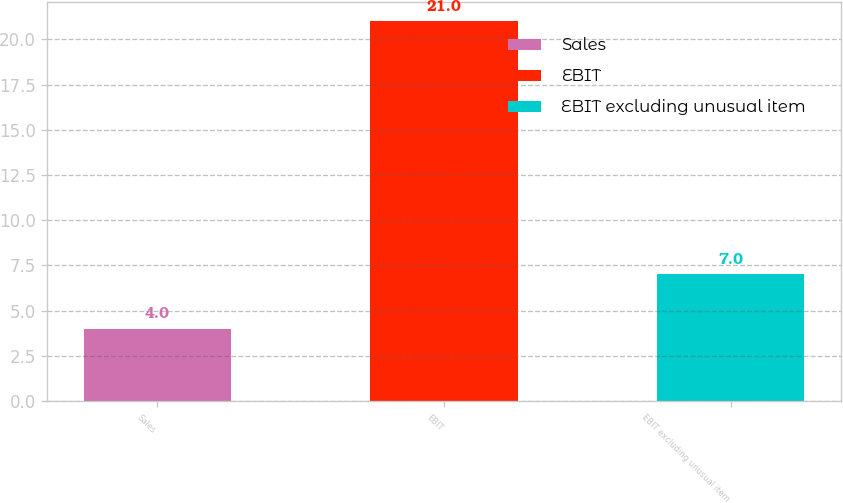<chart> <loc_0><loc_0><loc_500><loc_500><bar_chart><fcel>Sales<fcel>EBIT<fcel>EBIT excluding unusual item<nl><fcel>4<fcel>21<fcel>7<nl></chart> 